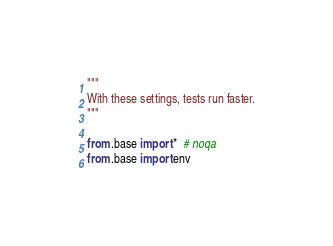Convert code to text. <code><loc_0><loc_0><loc_500><loc_500><_Python_>"""
With these settings, tests run faster.
"""

from .base import *  # noqa
from .base import env
</code> 